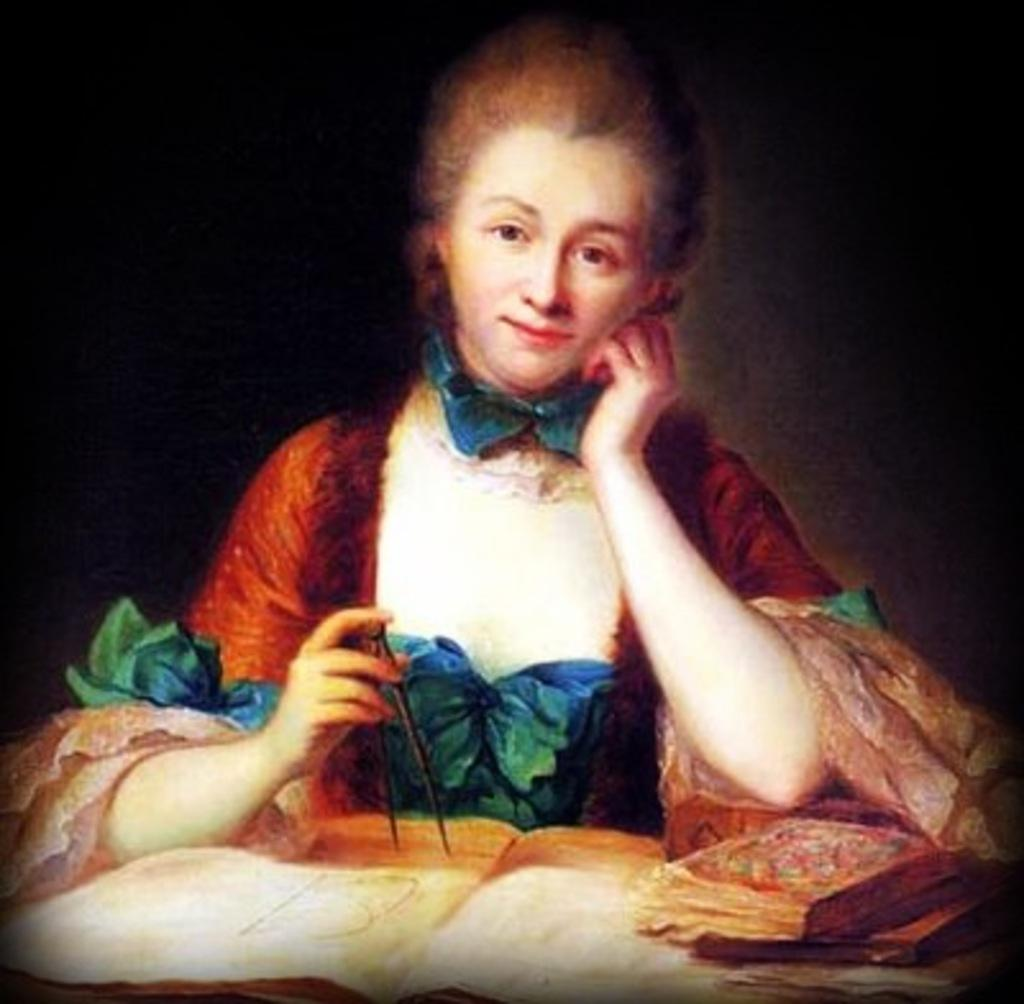Who is the main subject in the image? There is a woman in the image. What is the woman holding in the image? The woman is holding an object. What can be seen in front of the woman? There are books in front of the woman. How would you describe the background of the image? The background of the image is dark. What is the woman's opinion on the purpose of the cannon in the image? There is no cannon present in the image, so it is not possible to determine the woman's opinion on its purpose. 